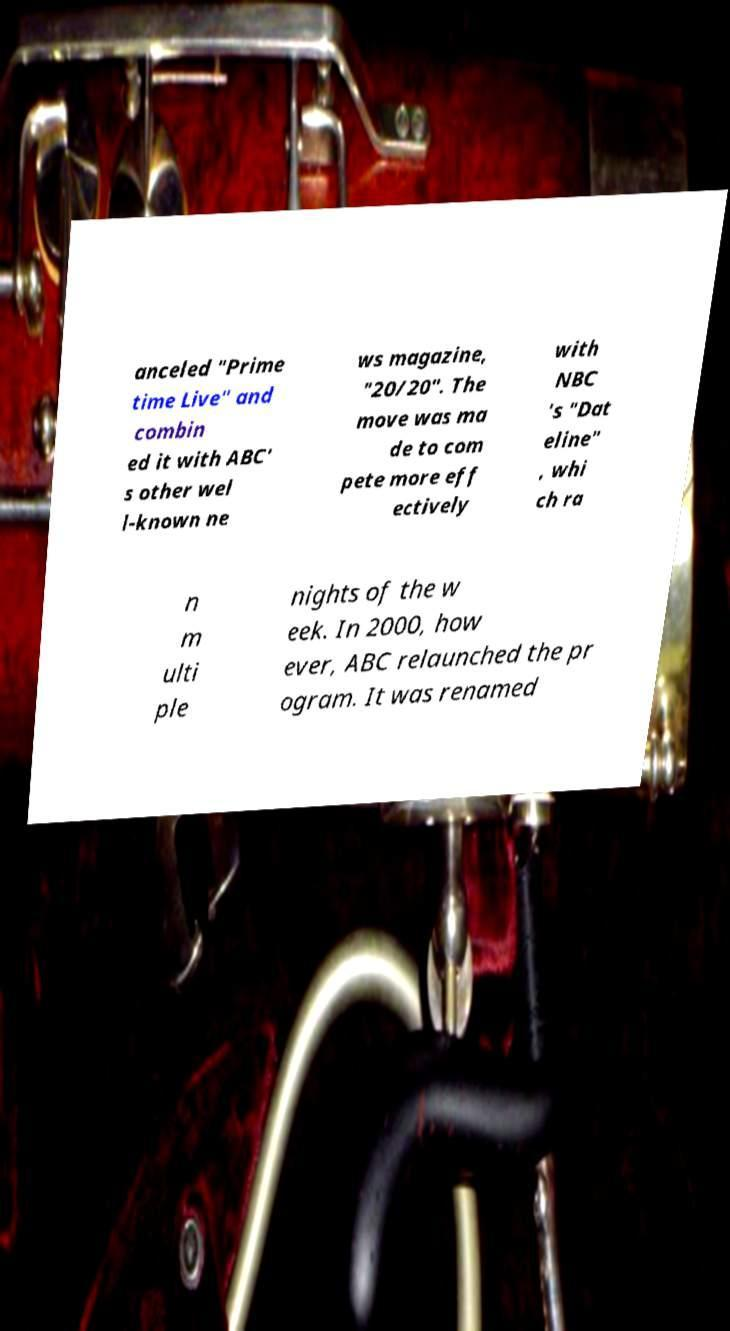There's text embedded in this image that I need extracted. Can you transcribe it verbatim? anceled "Prime time Live" and combin ed it with ABC' s other wel l-known ne ws magazine, "20/20". The move was ma de to com pete more eff ectively with NBC 's "Dat eline" , whi ch ra n m ulti ple nights of the w eek. In 2000, how ever, ABC relaunched the pr ogram. It was renamed 